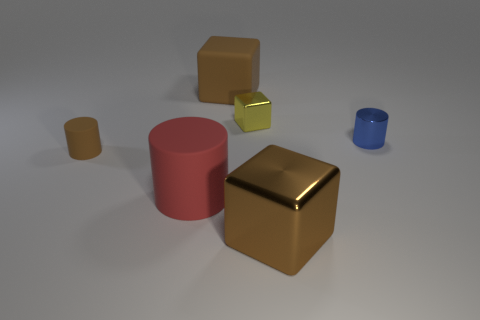Are there fewer brown rubber cylinders that are in front of the brown rubber cylinder than big purple metallic cylinders?
Provide a short and direct response. No. There is a tiny cylinder left of the big rubber object that is behind the tiny metallic cylinder; are there any brown cylinders to the right of it?
Your response must be concise. No. Are the small block and the brown thing to the left of the red cylinder made of the same material?
Keep it short and to the point. No. There is a shiny cube behind the matte object left of the red matte thing; what color is it?
Provide a short and direct response. Yellow. Is there a tiny metallic thing that has the same color as the small matte thing?
Ensure brevity in your answer.  No. There is a brown object to the right of the big brown object that is behind the large brown block that is in front of the tiny blue cylinder; how big is it?
Your answer should be very brief. Large. Does the blue object have the same shape as the rubber thing that is behind the brown cylinder?
Make the answer very short. No. What number of other objects are there of the same size as the brown rubber block?
Provide a short and direct response. 2. How big is the brown cube on the left side of the brown metal cube?
Ensure brevity in your answer.  Large. What number of tiny blue things have the same material as the big red cylinder?
Make the answer very short. 0. 